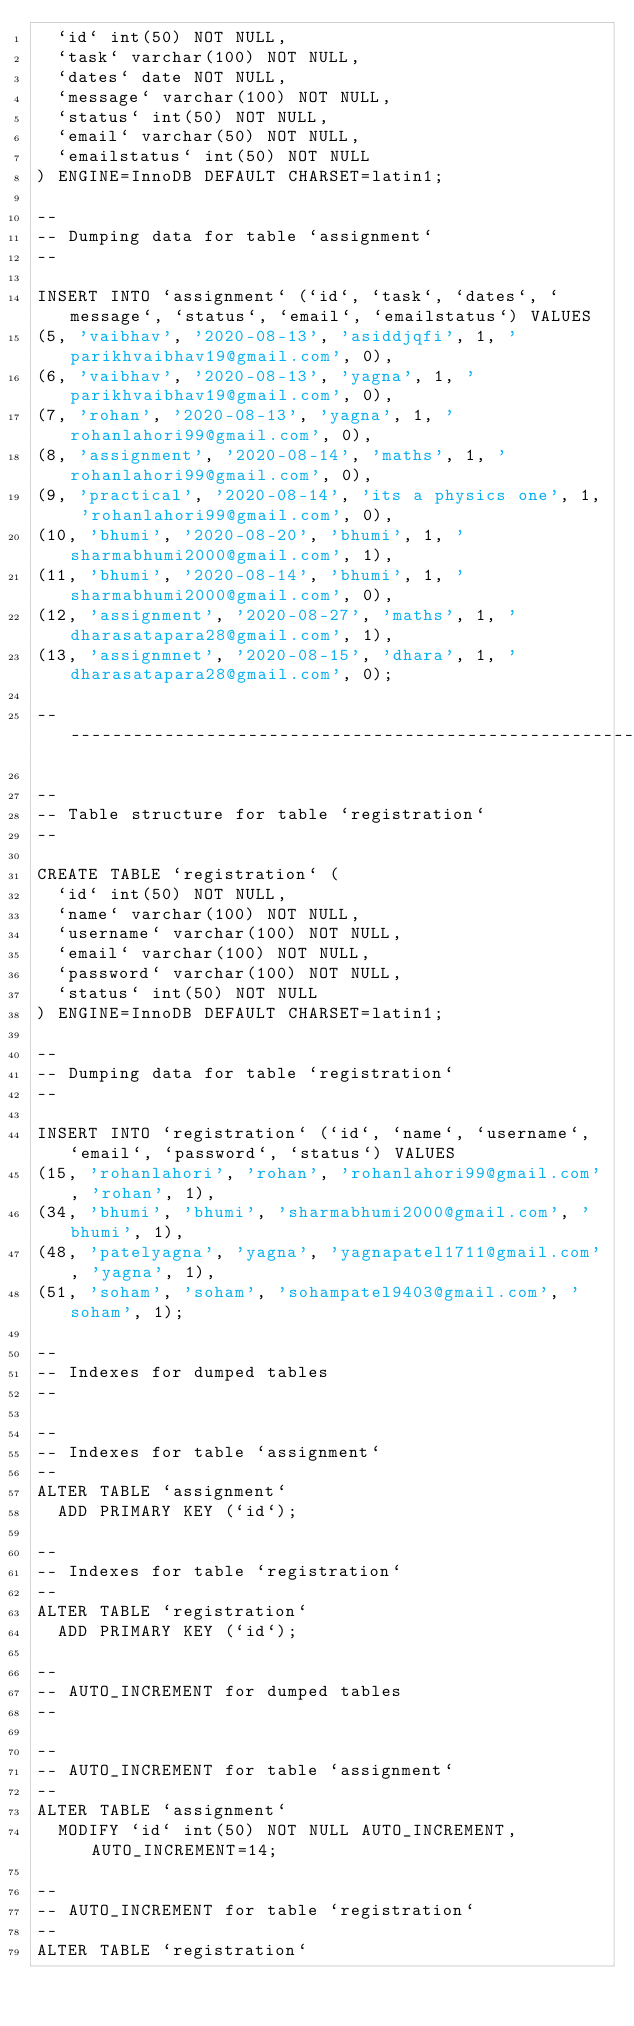Convert code to text. <code><loc_0><loc_0><loc_500><loc_500><_SQL_>  `id` int(50) NOT NULL,
  `task` varchar(100) NOT NULL,
  `dates` date NOT NULL,
  `message` varchar(100) NOT NULL,
  `status` int(50) NOT NULL,
  `email` varchar(50) NOT NULL,
  `emailstatus` int(50) NOT NULL
) ENGINE=InnoDB DEFAULT CHARSET=latin1;

--
-- Dumping data for table `assignment`
--

INSERT INTO `assignment` (`id`, `task`, `dates`, `message`, `status`, `email`, `emailstatus`) VALUES
(5, 'vaibhav', '2020-08-13', 'asiddjqfi', 1, 'parikhvaibhav19@gmail.com', 0),
(6, 'vaibhav', '2020-08-13', 'yagna', 1, 'parikhvaibhav19@gmail.com', 0),
(7, 'rohan', '2020-08-13', 'yagna', 1, 'rohanlahori99@gmail.com', 0),
(8, 'assignment', '2020-08-14', 'maths', 1, 'rohanlahori99@gmail.com', 0),
(9, 'practical', '2020-08-14', 'its a physics one', 1, 'rohanlahori99@gmail.com', 0),
(10, 'bhumi', '2020-08-20', 'bhumi', 1, 'sharmabhumi2000@gmail.com', 1),
(11, 'bhumi', '2020-08-14', 'bhumi', 1, 'sharmabhumi2000@gmail.com', 0),
(12, 'assignment', '2020-08-27', 'maths', 1, 'dharasatapara28@gmail.com', 1),
(13, 'assignmnet', '2020-08-15', 'dhara', 1, 'dharasatapara28@gmail.com', 0);

-- --------------------------------------------------------

--
-- Table structure for table `registration`
--

CREATE TABLE `registration` (
  `id` int(50) NOT NULL,
  `name` varchar(100) NOT NULL,
  `username` varchar(100) NOT NULL,
  `email` varchar(100) NOT NULL,
  `password` varchar(100) NOT NULL,
  `status` int(50) NOT NULL
) ENGINE=InnoDB DEFAULT CHARSET=latin1;

--
-- Dumping data for table `registration`
--

INSERT INTO `registration` (`id`, `name`, `username`, `email`, `password`, `status`) VALUES
(15, 'rohanlahori', 'rohan', 'rohanlahori99@gmail.com', 'rohan', 1),
(34, 'bhumi', 'bhumi', 'sharmabhumi2000@gmail.com', 'bhumi', 1),
(48, 'patelyagna', 'yagna', 'yagnapatel1711@gmail.com', 'yagna', 1),
(51, 'soham', 'soham', 'sohampatel9403@gmail.com', 'soham', 1);

--
-- Indexes for dumped tables
--

--
-- Indexes for table `assignment`
--
ALTER TABLE `assignment`
  ADD PRIMARY KEY (`id`);

--
-- Indexes for table `registration`
--
ALTER TABLE `registration`
  ADD PRIMARY KEY (`id`);

--
-- AUTO_INCREMENT for dumped tables
--

--
-- AUTO_INCREMENT for table `assignment`
--
ALTER TABLE `assignment`
  MODIFY `id` int(50) NOT NULL AUTO_INCREMENT, AUTO_INCREMENT=14;

--
-- AUTO_INCREMENT for table `registration`
--
ALTER TABLE `registration`</code> 